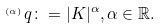Convert formula to latex. <formula><loc_0><loc_0><loc_500><loc_500>^ { _ { ( \alpha ) } } q \colon = | K | ^ { \alpha } , \alpha \in \mathbb { R } .</formula> 